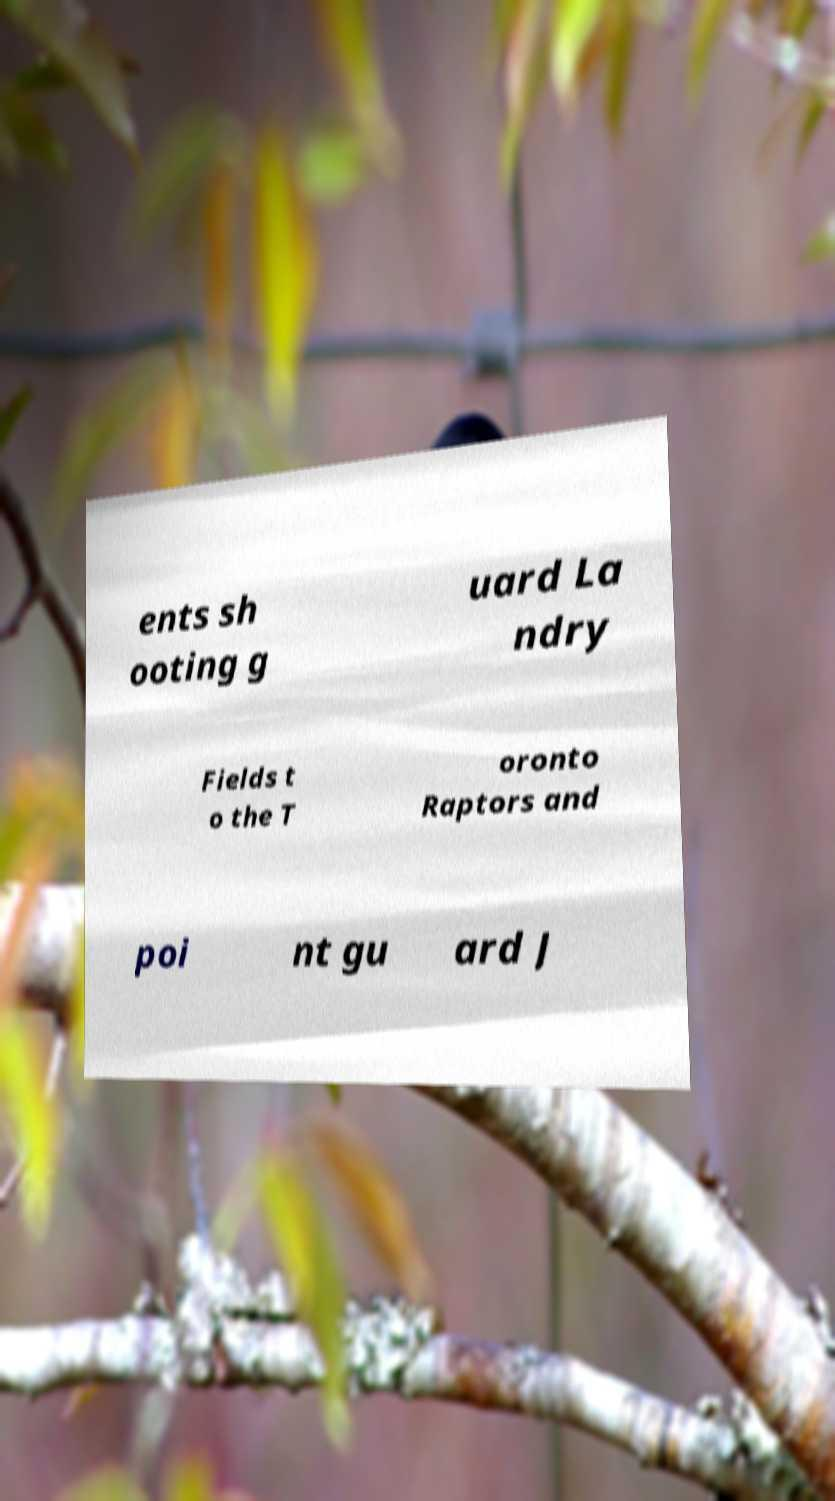Can you read and provide the text displayed in the image?This photo seems to have some interesting text. Can you extract and type it out for me? ents sh ooting g uard La ndry Fields t o the T oronto Raptors and poi nt gu ard J 